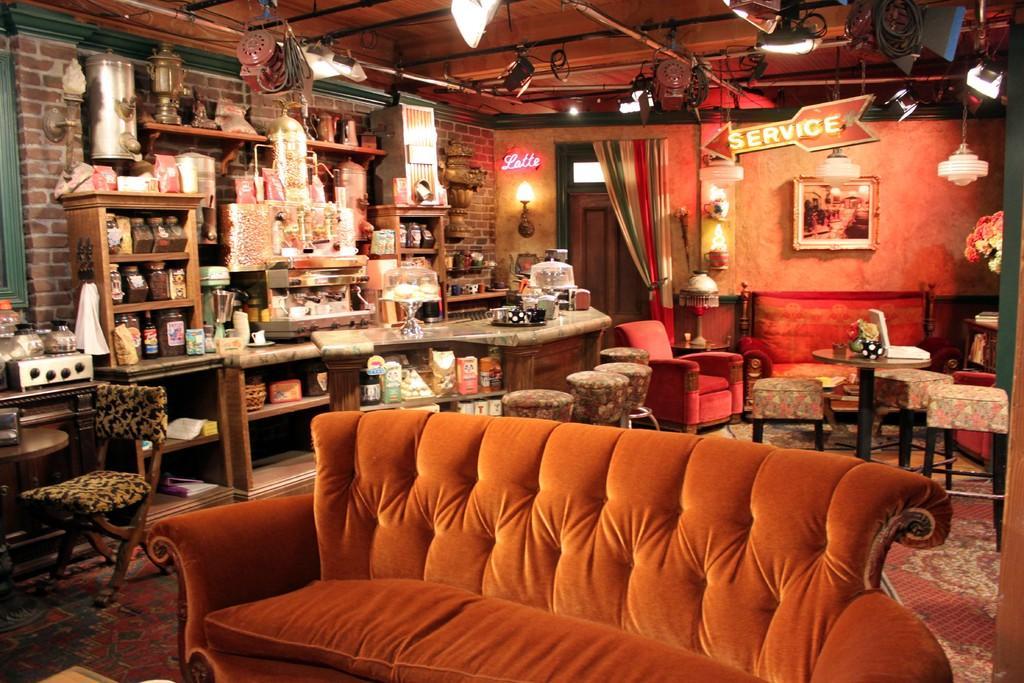Could you give a brief overview of what you see in this image? An indoor picture. In this race there are things. This is an orange couch. Far there are chairs. On top there are lights. Picture on wall. 